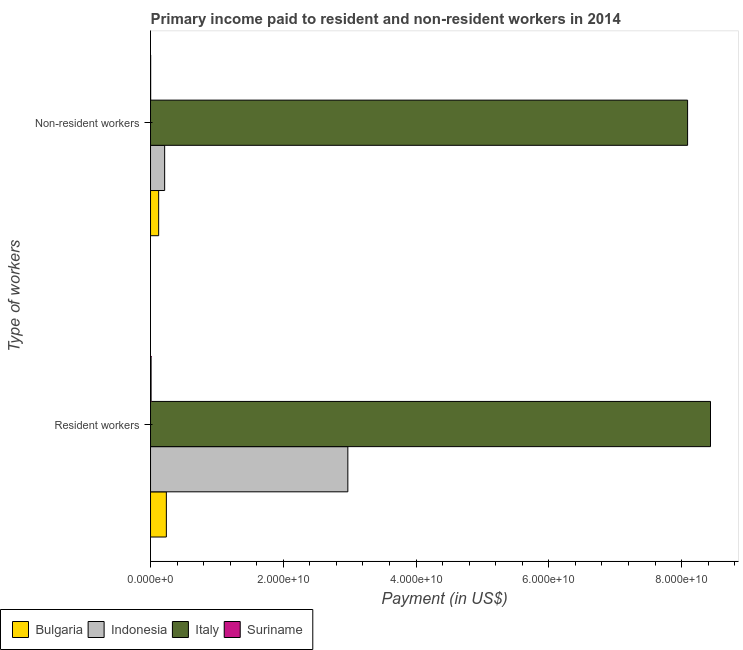Are the number of bars per tick equal to the number of legend labels?
Make the answer very short. Yes. Are the number of bars on each tick of the Y-axis equal?
Provide a short and direct response. Yes. What is the label of the 2nd group of bars from the top?
Your response must be concise. Resident workers. What is the payment made to resident workers in Italy?
Make the answer very short. 8.44e+1. Across all countries, what is the maximum payment made to non-resident workers?
Your answer should be compact. 8.09e+1. Across all countries, what is the minimum payment made to non-resident workers?
Your answer should be compact. 2.16e+07. In which country was the payment made to resident workers maximum?
Give a very brief answer. Italy. In which country was the payment made to non-resident workers minimum?
Offer a terse response. Suriname. What is the total payment made to non-resident workers in the graph?
Keep it short and to the point. 8.43e+1. What is the difference between the payment made to resident workers in Suriname and that in Italy?
Ensure brevity in your answer.  -8.43e+1. What is the difference between the payment made to non-resident workers in Bulgaria and the payment made to resident workers in Indonesia?
Offer a terse response. -2.85e+1. What is the average payment made to non-resident workers per country?
Provide a succinct answer. 2.11e+1. What is the difference between the payment made to resident workers and payment made to non-resident workers in Suriname?
Ensure brevity in your answer.  6.10e+07. What is the ratio of the payment made to non-resident workers in Indonesia to that in Italy?
Your response must be concise. 0.03. In how many countries, is the payment made to non-resident workers greater than the average payment made to non-resident workers taken over all countries?
Provide a succinct answer. 1. How many bars are there?
Provide a succinct answer. 8. Are all the bars in the graph horizontal?
Offer a very short reply. Yes. Does the graph contain any zero values?
Ensure brevity in your answer.  No. Where does the legend appear in the graph?
Make the answer very short. Bottom left. How many legend labels are there?
Ensure brevity in your answer.  4. What is the title of the graph?
Your answer should be very brief. Primary income paid to resident and non-resident workers in 2014. What is the label or title of the X-axis?
Offer a terse response. Payment (in US$). What is the label or title of the Y-axis?
Provide a short and direct response. Type of workers. What is the Payment (in US$) in Bulgaria in Resident workers?
Give a very brief answer. 2.39e+09. What is the Payment (in US$) of Indonesia in Resident workers?
Offer a terse response. 2.97e+1. What is the Payment (in US$) in Italy in Resident workers?
Your response must be concise. 8.44e+1. What is the Payment (in US$) of Suriname in Resident workers?
Provide a succinct answer. 8.26e+07. What is the Payment (in US$) of Bulgaria in Non-resident workers?
Ensure brevity in your answer.  1.22e+09. What is the Payment (in US$) in Indonesia in Non-resident workers?
Provide a succinct answer. 2.13e+09. What is the Payment (in US$) of Italy in Non-resident workers?
Make the answer very short. 8.09e+1. What is the Payment (in US$) of Suriname in Non-resident workers?
Your answer should be compact. 2.16e+07. Across all Type of workers, what is the maximum Payment (in US$) in Bulgaria?
Ensure brevity in your answer.  2.39e+09. Across all Type of workers, what is the maximum Payment (in US$) of Indonesia?
Offer a very short reply. 2.97e+1. Across all Type of workers, what is the maximum Payment (in US$) in Italy?
Ensure brevity in your answer.  8.44e+1. Across all Type of workers, what is the maximum Payment (in US$) of Suriname?
Your response must be concise. 8.26e+07. Across all Type of workers, what is the minimum Payment (in US$) in Bulgaria?
Your answer should be compact. 1.22e+09. Across all Type of workers, what is the minimum Payment (in US$) in Indonesia?
Keep it short and to the point. 2.13e+09. Across all Type of workers, what is the minimum Payment (in US$) of Italy?
Give a very brief answer. 8.09e+1. Across all Type of workers, what is the minimum Payment (in US$) of Suriname?
Provide a succinct answer. 2.16e+07. What is the total Payment (in US$) of Bulgaria in the graph?
Your response must be concise. 3.61e+09. What is the total Payment (in US$) in Indonesia in the graph?
Provide a succinct answer. 3.19e+1. What is the total Payment (in US$) of Italy in the graph?
Ensure brevity in your answer.  1.65e+11. What is the total Payment (in US$) in Suriname in the graph?
Offer a terse response. 1.04e+08. What is the difference between the Payment (in US$) in Bulgaria in Resident workers and that in Non-resident workers?
Your answer should be compact. 1.16e+09. What is the difference between the Payment (in US$) of Indonesia in Resident workers and that in Non-resident workers?
Offer a terse response. 2.76e+1. What is the difference between the Payment (in US$) in Italy in Resident workers and that in Non-resident workers?
Provide a short and direct response. 3.45e+09. What is the difference between the Payment (in US$) of Suriname in Resident workers and that in Non-resident workers?
Your answer should be compact. 6.10e+07. What is the difference between the Payment (in US$) of Bulgaria in Resident workers and the Payment (in US$) of Indonesia in Non-resident workers?
Offer a terse response. 2.57e+08. What is the difference between the Payment (in US$) of Bulgaria in Resident workers and the Payment (in US$) of Italy in Non-resident workers?
Your response must be concise. -7.85e+1. What is the difference between the Payment (in US$) in Bulgaria in Resident workers and the Payment (in US$) in Suriname in Non-resident workers?
Ensure brevity in your answer.  2.36e+09. What is the difference between the Payment (in US$) in Indonesia in Resident workers and the Payment (in US$) in Italy in Non-resident workers?
Your response must be concise. -5.12e+1. What is the difference between the Payment (in US$) of Indonesia in Resident workers and the Payment (in US$) of Suriname in Non-resident workers?
Provide a succinct answer. 2.97e+1. What is the difference between the Payment (in US$) of Italy in Resident workers and the Payment (in US$) of Suriname in Non-resident workers?
Provide a succinct answer. 8.43e+1. What is the average Payment (in US$) of Bulgaria per Type of workers?
Keep it short and to the point. 1.80e+09. What is the average Payment (in US$) in Indonesia per Type of workers?
Ensure brevity in your answer.  1.59e+1. What is the average Payment (in US$) of Italy per Type of workers?
Ensure brevity in your answer.  8.26e+1. What is the average Payment (in US$) in Suriname per Type of workers?
Give a very brief answer. 5.21e+07. What is the difference between the Payment (in US$) of Bulgaria and Payment (in US$) of Indonesia in Resident workers?
Offer a very short reply. -2.73e+1. What is the difference between the Payment (in US$) in Bulgaria and Payment (in US$) in Italy in Resident workers?
Ensure brevity in your answer.  -8.20e+1. What is the difference between the Payment (in US$) of Bulgaria and Payment (in US$) of Suriname in Resident workers?
Provide a succinct answer. 2.30e+09. What is the difference between the Payment (in US$) of Indonesia and Payment (in US$) of Italy in Resident workers?
Give a very brief answer. -5.46e+1. What is the difference between the Payment (in US$) in Indonesia and Payment (in US$) in Suriname in Resident workers?
Make the answer very short. 2.96e+1. What is the difference between the Payment (in US$) of Italy and Payment (in US$) of Suriname in Resident workers?
Keep it short and to the point. 8.43e+1. What is the difference between the Payment (in US$) of Bulgaria and Payment (in US$) of Indonesia in Non-resident workers?
Your answer should be compact. -9.05e+08. What is the difference between the Payment (in US$) in Bulgaria and Payment (in US$) in Italy in Non-resident workers?
Provide a succinct answer. -7.97e+1. What is the difference between the Payment (in US$) of Bulgaria and Payment (in US$) of Suriname in Non-resident workers?
Give a very brief answer. 1.20e+09. What is the difference between the Payment (in US$) in Indonesia and Payment (in US$) in Italy in Non-resident workers?
Ensure brevity in your answer.  -7.88e+1. What is the difference between the Payment (in US$) of Indonesia and Payment (in US$) of Suriname in Non-resident workers?
Make the answer very short. 2.11e+09. What is the difference between the Payment (in US$) of Italy and Payment (in US$) of Suriname in Non-resident workers?
Provide a succinct answer. 8.09e+1. What is the ratio of the Payment (in US$) in Bulgaria in Resident workers to that in Non-resident workers?
Your response must be concise. 1.95. What is the ratio of the Payment (in US$) of Indonesia in Resident workers to that in Non-resident workers?
Provide a short and direct response. 13.96. What is the ratio of the Payment (in US$) of Italy in Resident workers to that in Non-resident workers?
Offer a very short reply. 1.04. What is the ratio of the Payment (in US$) of Suriname in Resident workers to that in Non-resident workers?
Give a very brief answer. 3.82. What is the difference between the highest and the second highest Payment (in US$) of Bulgaria?
Offer a very short reply. 1.16e+09. What is the difference between the highest and the second highest Payment (in US$) in Indonesia?
Your answer should be compact. 2.76e+1. What is the difference between the highest and the second highest Payment (in US$) in Italy?
Offer a terse response. 3.45e+09. What is the difference between the highest and the second highest Payment (in US$) of Suriname?
Your response must be concise. 6.10e+07. What is the difference between the highest and the lowest Payment (in US$) in Bulgaria?
Provide a short and direct response. 1.16e+09. What is the difference between the highest and the lowest Payment (in US$) in Indonesia?
Keep it short and to the point. 2.76e+1. What is the difference between the highest and the lowest Payment (in US$) in Italy?
Your answer should be compact. 3.45e+09. What is the difference between the highest and the lowest Payment (in US$) of Suriname?
Your response must be concise. 6.10e+07. 